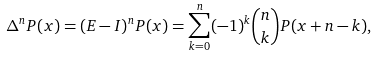<formula> <loc_0><loc_0><loc_500><loc_500>\Delta ^ { n } P ( x ) = ( E - I ) ^ { n } P ( x ) = \sum _ { k = 0 } ^ { n } ( - 1 ) ^ { k } \binom { n } { k } P ( x + n - k ) ,</formula> 